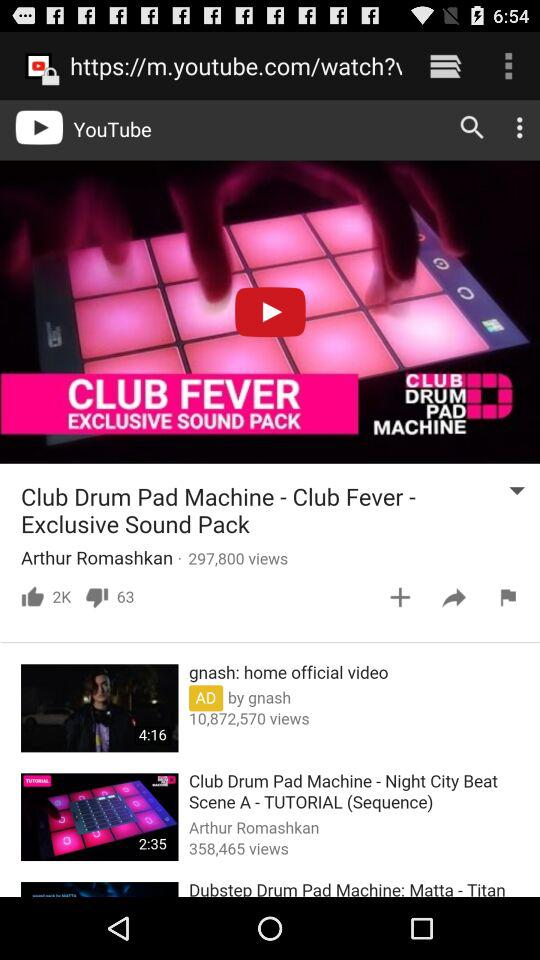How many views are there for "Club Drum Pad Machine - Club Fever"? There are 297,800 views. 